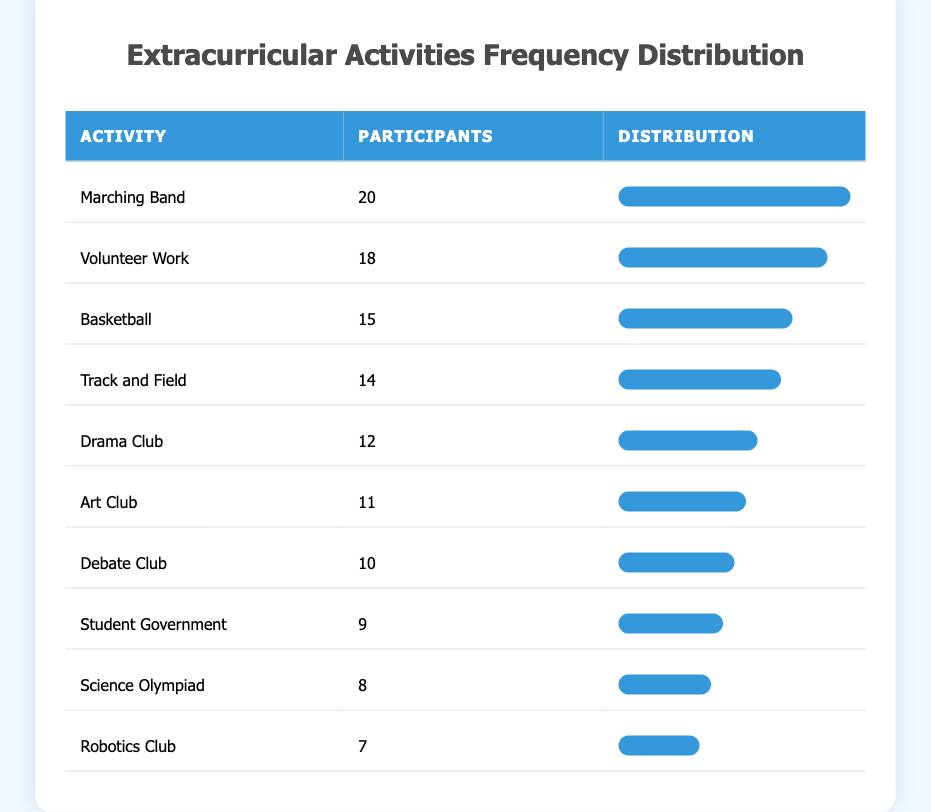What is the most popular extracurricular activity? The most popular activity can be found by looking for the highest number of participants. In the table, "Marching Band" has the highest number with 20 participants.
Answer: Marching Band How many participants are involved in the Debate Club? The number of participants in the Debate Club is clearly listed in the table. It shows that there are 10 participants.
Answer: 10 What are the top three extracurricular activities based on participation? To find the top three, we look for the activities with the highest numbers of participants. The top three are "Marching Band" with 20, "Volunteer Work" with 18, and "Basketball" with 15.
Answer: Marching Band, Volunteer Work, Basketball Is there more participation in the Track and Field than the Robotics Club? We compare the values for "Track and Field" which has 14 participants and "Robotics Club" which has 7 participants. Since 14 is greater than 7, the statement is true.
Answer: Yes What is the total number of participants in all activities listed? To calculate the total, we add all the participant numbers: 20 + 18 + 15 + 14 + 12 + 11 + 10 + 9 + 8 + 7 = 132 participants in total.
Answer: 132 What is the difference in participation between the most and least popular activities? The most popular activity, "Marching Band," has 20 participants, while the least popular, "Robotics Club," has 7. The difference is calculated as 20 - 7 = 13.
Answer: 13 How many extracurricular activities have more than 10 participants? We review the table and count the activities with more than 10 participants: Marching Band, Volunteer Work, Basketball, Track and Field, Drama Club, and Art Club, resulting in a total of 6 activities.
Answer: 6 Is it true that more students are involved in Student Government than Science Olympiad? By comparing the participants, "Student Government" has 9, while "Science Olympiad" has 8. Since 9 is greater than 8, the statement is true.
Answer: Yes What is the average number of participants across all extracurricular activities? The total number of participants is 132. Since there are 10 activities, we calculate the average by dividing 132 by 10, resulting in 13.2 participants on average.
Answer: 13.2 